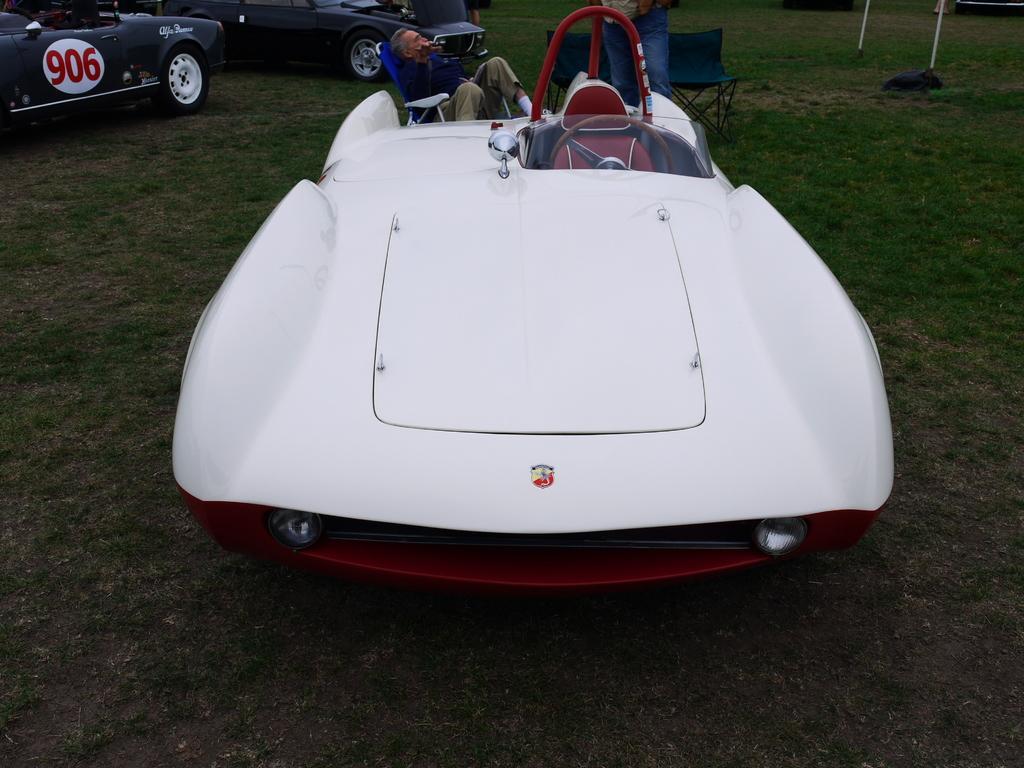Can you describe this image briefly? In this image, we can see three vehicles are on the grass. Top of the image, we can see two people. Here a person is sitting on the chair. Here we can see chairs, poles. 